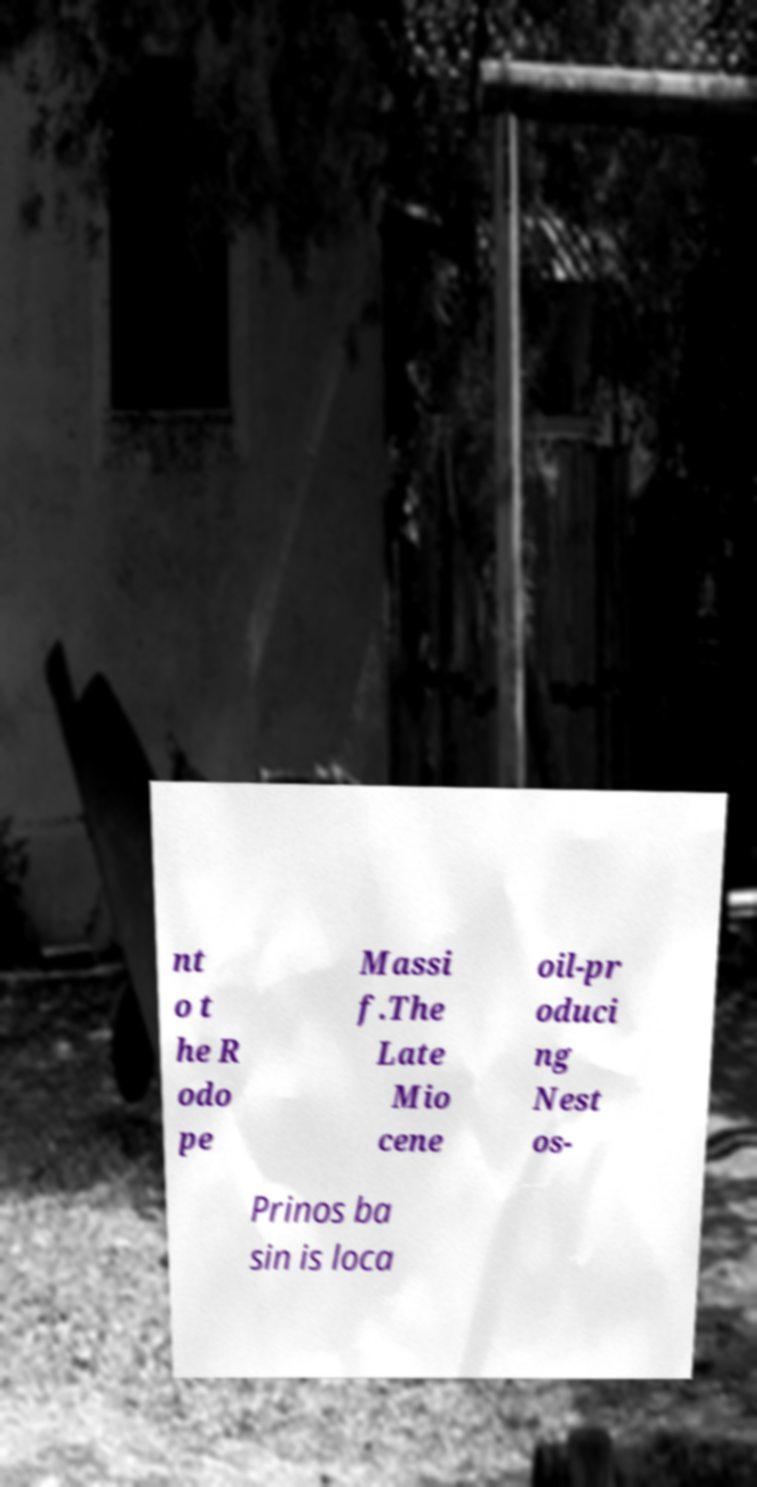Can you read and provide the text displayed in the image?This photo seems to have some interesting text. Can you extract and type it out for me? nt o t he R odo pe Massi f.The Late Mio cene oil-pr oduci ng Nest os- Prinos ba sin is loca 